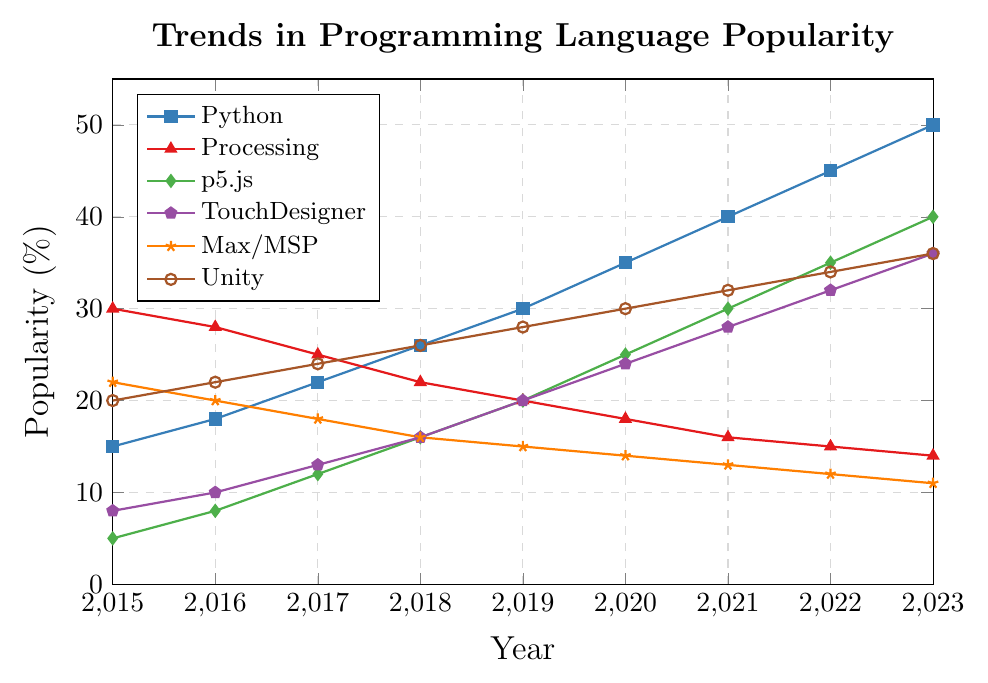What's the most popular programming language in 2023? From the figure, in 2023, Python has the highest popularity at 50%.
Answer: Python Which language had a steady increase in popularity throughout all the years? By inspecting the trend lines, Unity displays a steady rise in popularity from 2015 to 2023 without any decrease.
Answer: Unity Which language experienced the greatest decrease in popularity from 2015 to 2023? From the data, Processing started at 30% in 2015 and decreased to 14% in 2023, a total drop of 16 percentage points.
Answer: Processing How does the popularity of Python in 2018 compare to the popularity of TouchDesigner in 2021? In 2018, Python's popularity is 26%. TouchDesigner's popularity in 2021 is 28%. Therefore, TouchDesigner in 2021 is more popular than Python in 2018.
Answer: TouchDesigner is more popular What is the average popularity of Max/MSP over all the years depicted in the chart? The percentages for Max/MSP are 22, 20, 18, 16, 15, 14, 13, 12, and 11. Summing these: 22 + 20 + 18 + 16 + 15 + 14 + 13 + 12 + 11 = 141. There are 9 values, so the average is 141 / 9 = 15.67%
Answer: 15.67% Which languages have crossed each other in terms of popularity? From the visual analysis, Python and Processing crossed each other between 2017 and 2018, with Python increasing and Processing decreasing.
Answer: Python and Processing In which year did p5.js overtake Processing in popularity? Observing the lines, p5.js surpassed Processing in popularity around the year 2019.
Answer: 2019 What is the difference in popularity between Unity and TouchDesigner in 2023? In 2023, Unity's popularity is 36%, and TouchDesigner's popularity is also 36%. The difference in popularity between Unity and TouchDesigner is 36% - 36% = 0%.
Answer: 0% Rank the languages in terms of popularity in 2020 from highest to lowest. Checking each language's data for 2020: Python (35%), Unity (30%), p5.js (25%), TouchDesigner (24%), Processing (18%), and Max/MSP (14%). The ranking is: Python, Unity, p5.js, TouchDesigner, Processing, Max/MSP.
Answer: Python, Unity, p5.js, TouchDesigner, Processing, Max/MSP What is the cumulative (total) increase in popularity of TouchDesigner from 2015 to 2023? The initial popularity of TouchDesigner in 2015 is 8%, and in 2023 it is 36%. The cumulative increase is 36% - 8% = 28%.
Answer: 28% 